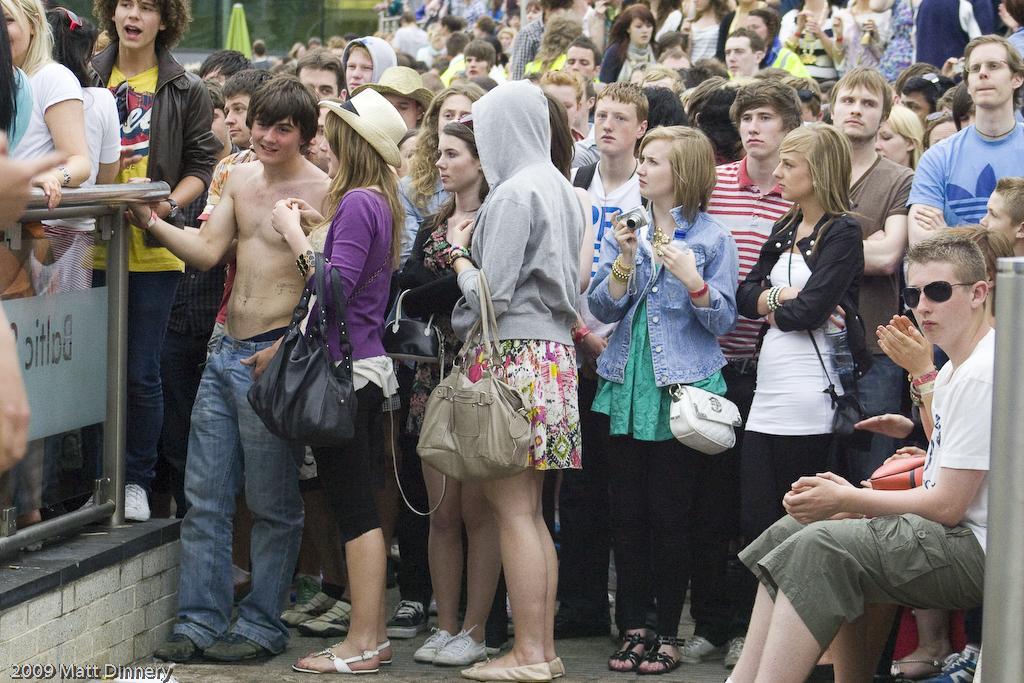Can you describe this image briefly? In this image we can see a group of people standing. In that some woman are are carrying the bags and a woman is holding a camera. On the right side we can see some people sitting. On the left side we can see a fence. 